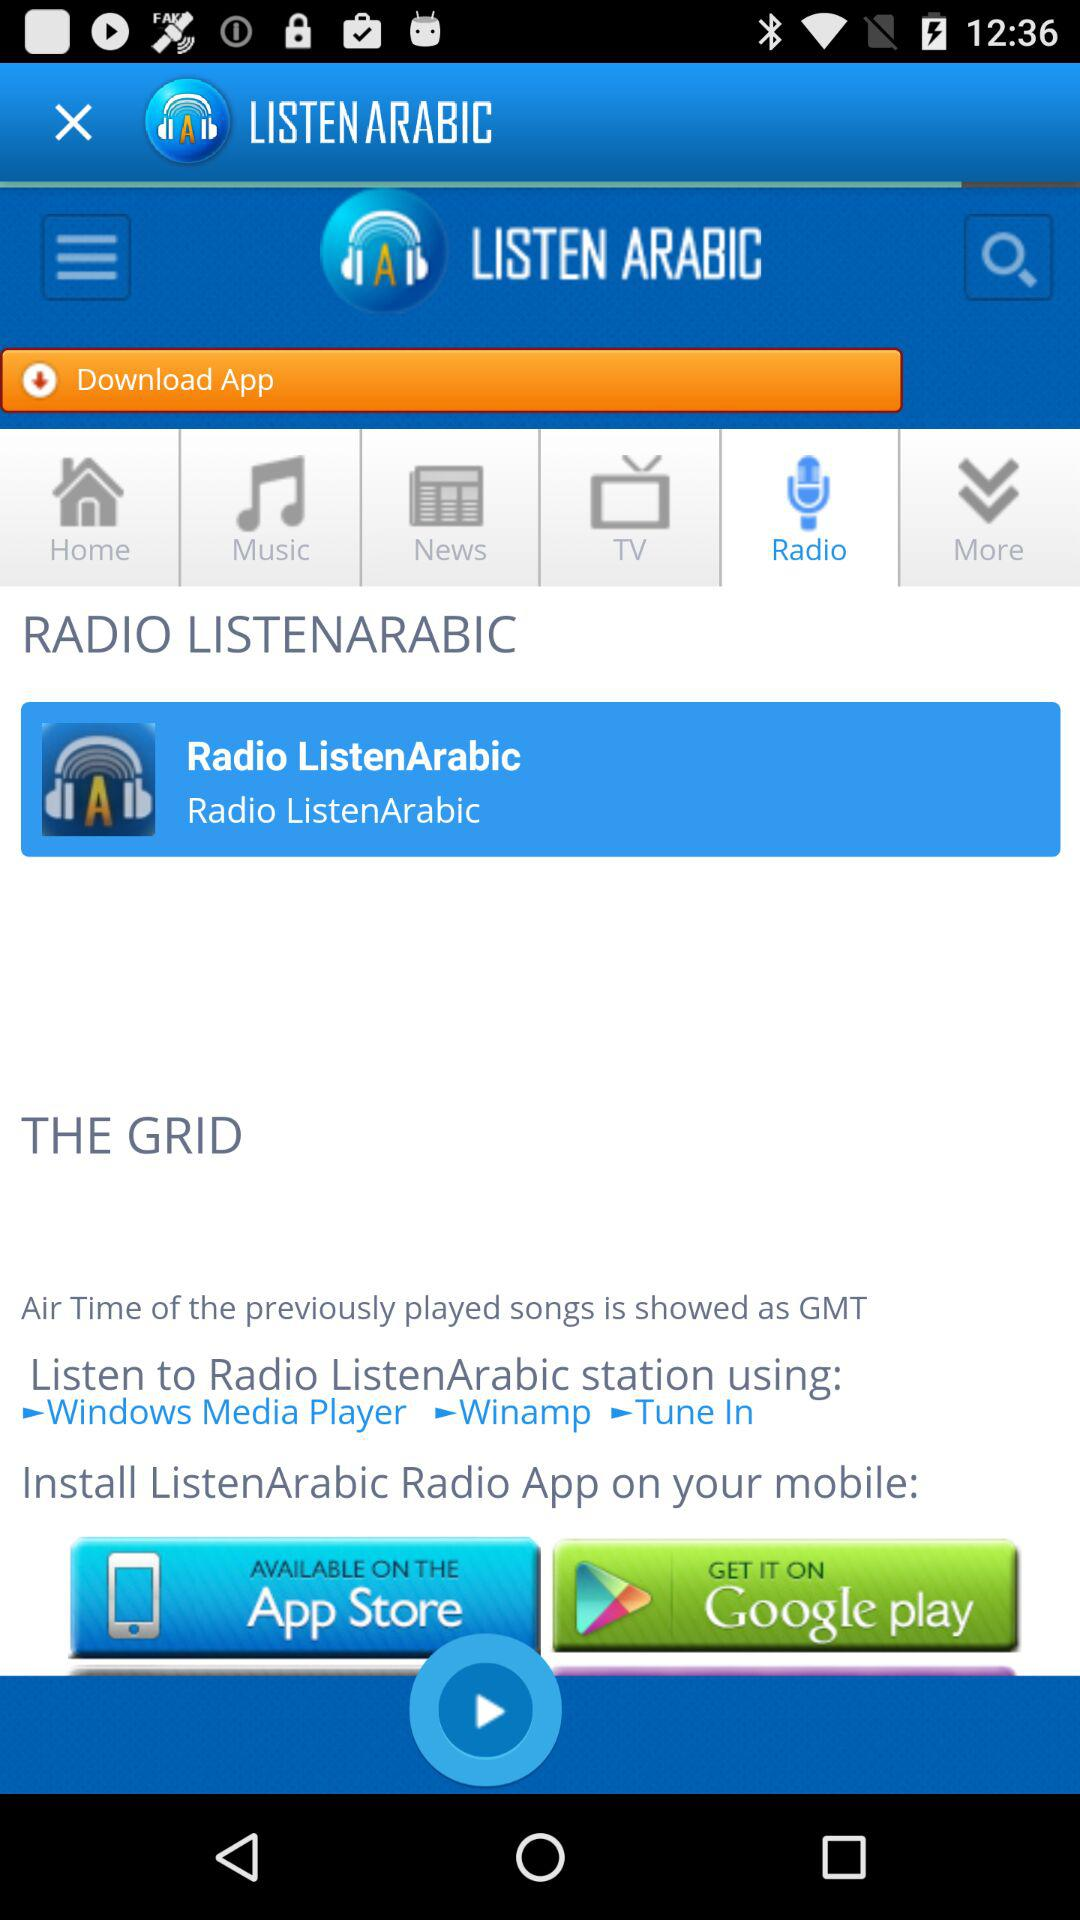From where can we get the app? You can get it on the "App Store" and "Google play". 